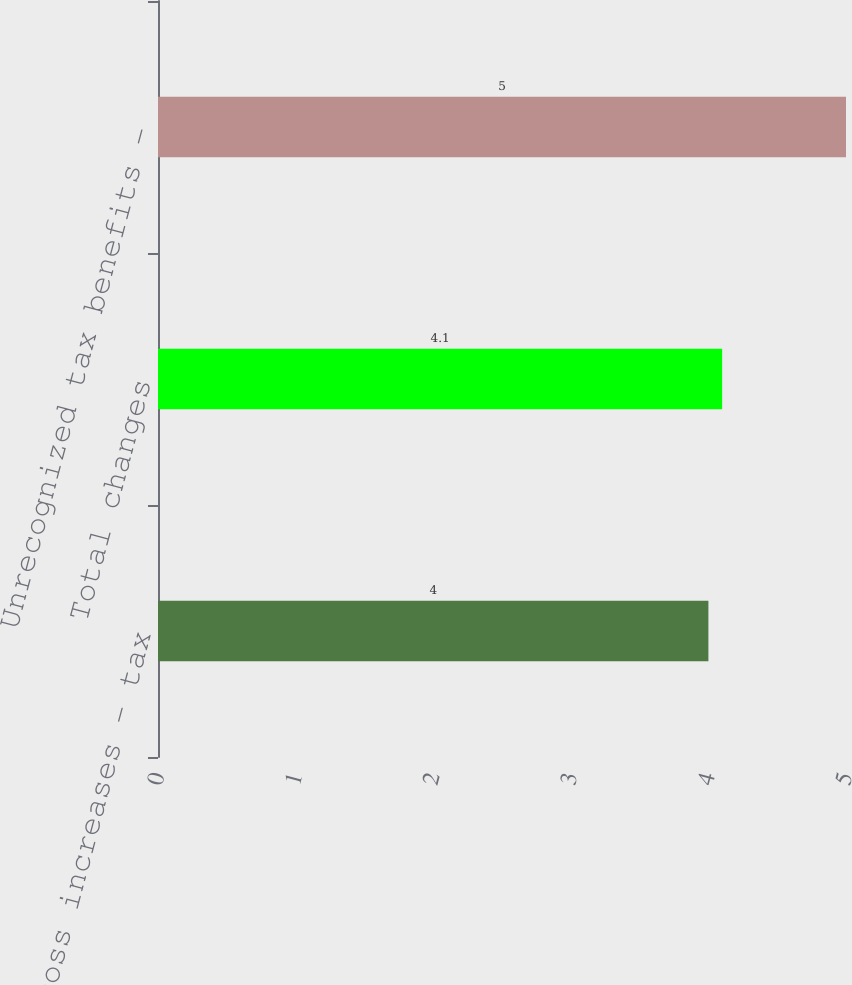Convert chart to OTSL. <chart><loc_0><loc_0><loc_500><loc_500><bar_chart><fcel>Gross increases - tax<fcel>Total changes<fcel>Unrecognized tax benefits -<nl><fcel>4<fcel>4.1<fcel>5<nl></chart> 